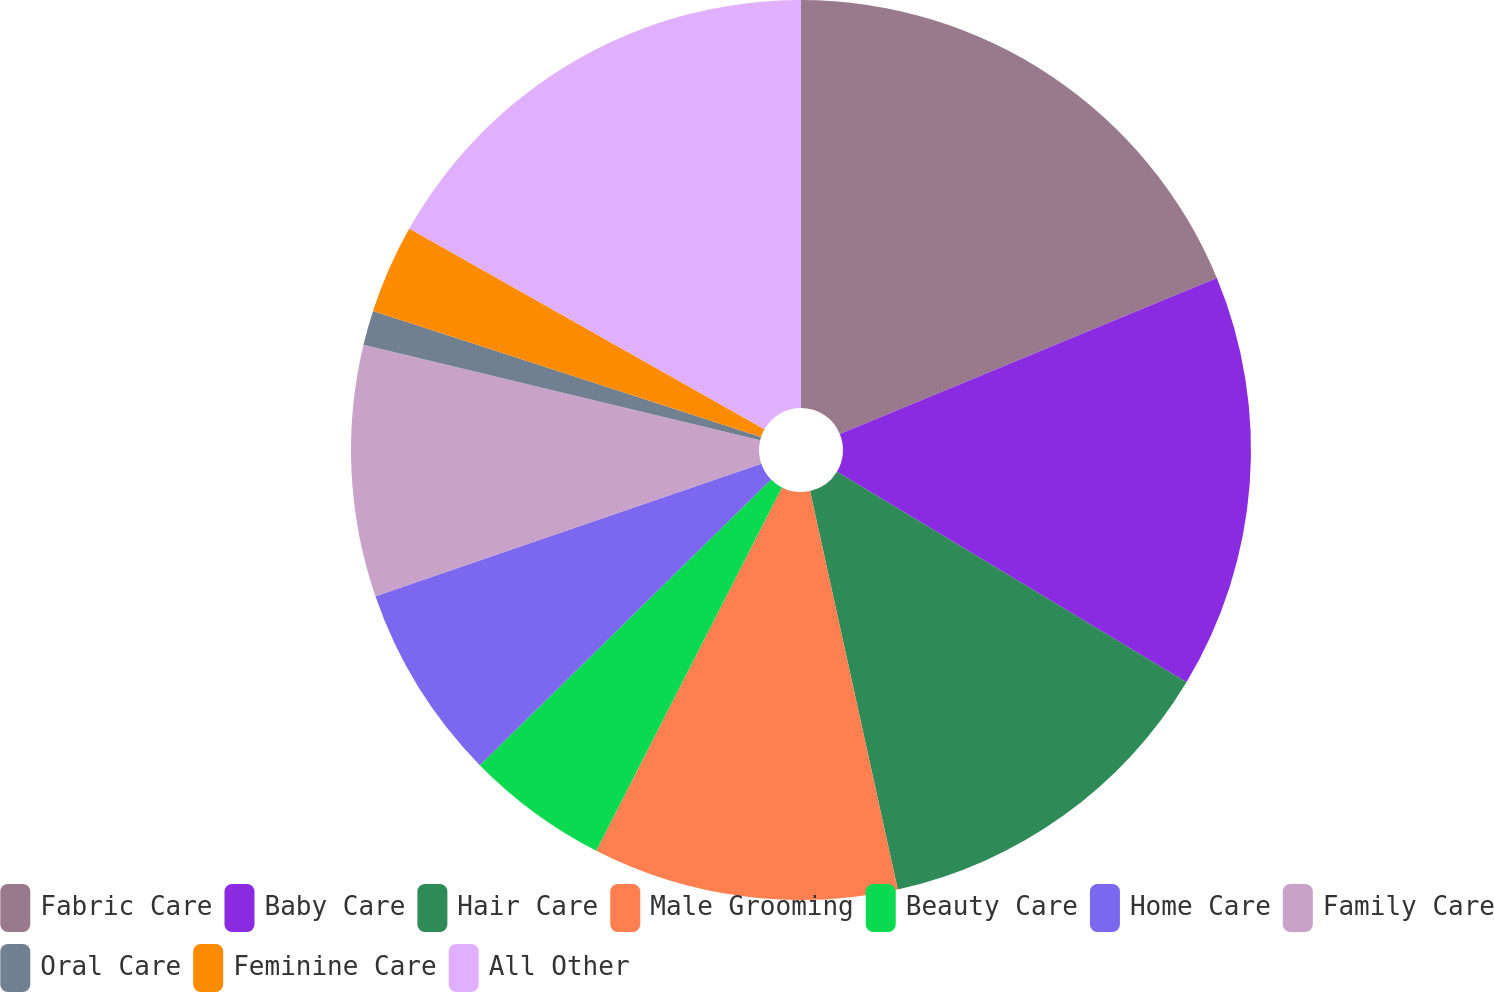Convert chart. <chart><loc_0><loc_0><loc_500><loc_500><pie_chart><fcel>Fabric Care<fcel>Baby Care<fcel>Hair Care<fcel>Male Grooming<fcel>Beauty Care<fcel>Home Care<fcel>Family Care<fcel>Oral Care<fcel>Feminine Care<fcel>All Other<nl><fcel>18.76%<fcel>14.87%<fcel>12.92%<fcel>10.97%<fcel>5.13%<fcel>7.08%<fcel>9.03%<fcel>1.24%<fcel>3.19%<fcel>16.81%<nl></chart> 